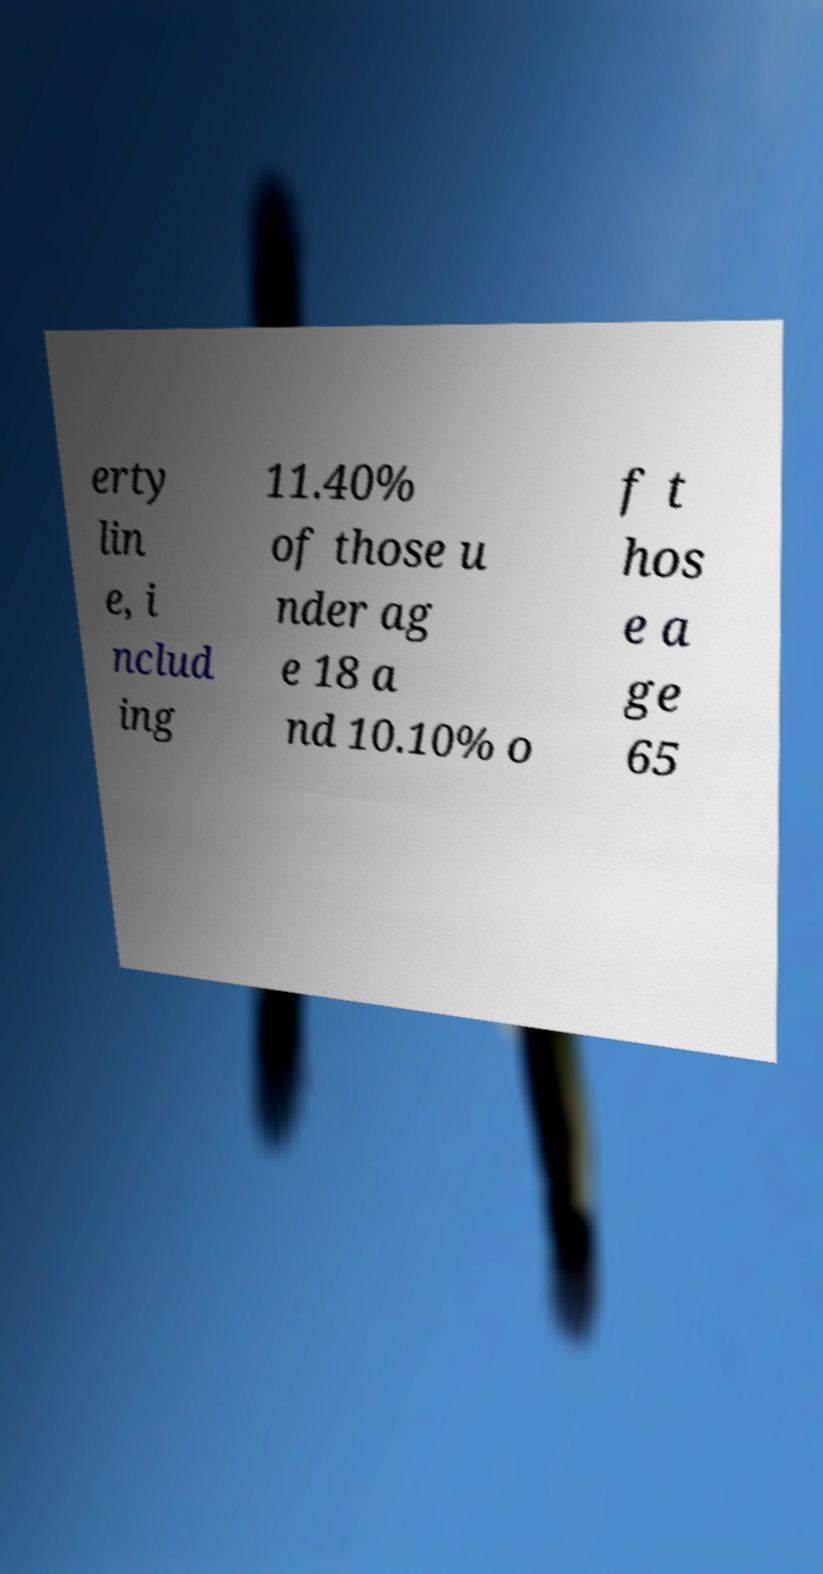Please identify and transcribe the text found in this image. erty lin e, i nclud ing 11.40% of those u nder ag e 18 a nd 10.10% o f t hos e a ge 65 